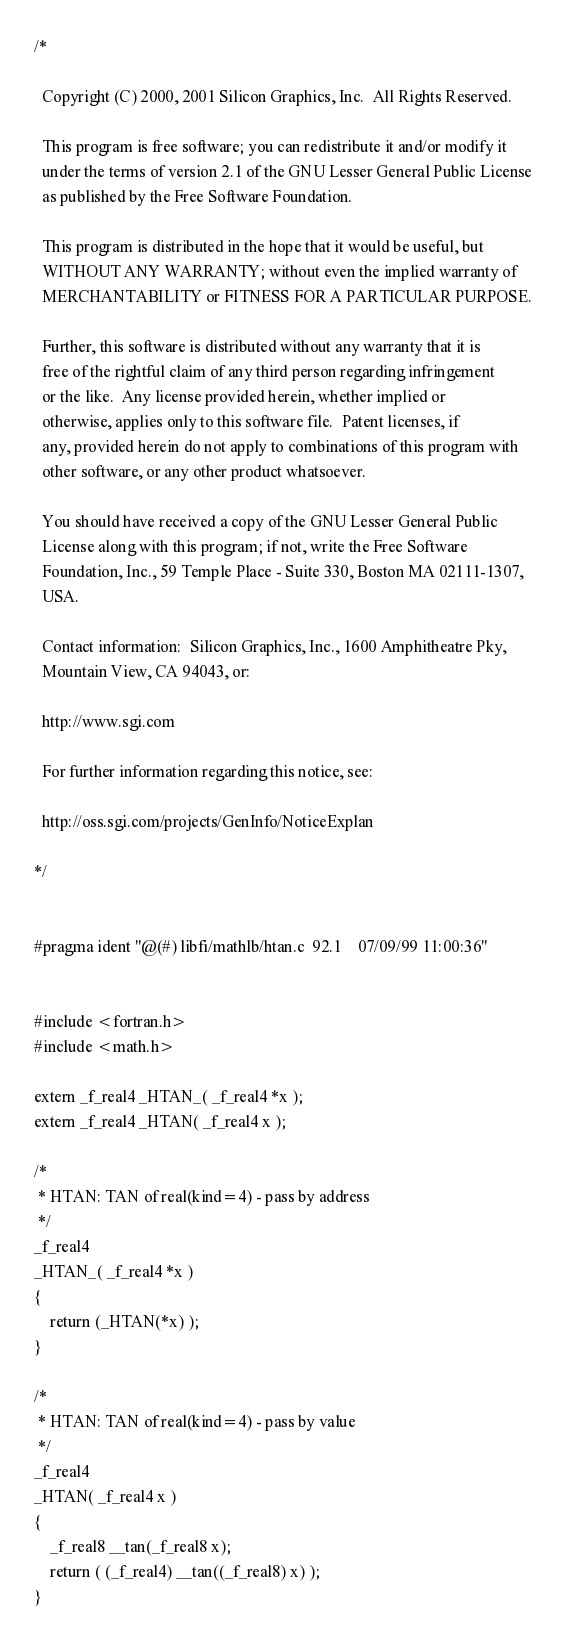Convert code to text. <code><loc_0><loc_0><loc_500><loc_500><_C_>/*

  Copyright (C) 2000, 2001 Silicon Graphics, Inc.  All Rights Reserved.

  This program is free software; you can redistribute it and/or modify it
  under the terms of version 2.1 of the GNU Lesser General Public License 
  as published by the Free Software Foundation.

  This program is distributed in the hope that it would be useful, but
  WITHOUT ANY WARRANTY; without even the implied warranty of
  MERCHANTABILITY or FITNESS FOR A PARTICULAR PURPOSE.  

  Further, this software is distributed without any warranty that it is
  free of the rightful claim of any third person regarding infringement 
  or the like.  Any license provided herein, whether implied or 
  otherwise, applies only to this software file.  Patent licenses, if
  any, provided herein do not apply to combinations of this program with 
  other software, or any other product whatsoever.  

  You should have received a copy of the GNU Lesser General Public 
  License along with this program; if not, write the Free Software 
  Foundation, Inc., 59 Temple Place - Suite 330, Boston MA 02111-1307, 
  USA.

  Contact information:  Silicon Graphics, Inc., 1600 Amphitheatre Pky,
  Mountain View, CA 94043, or:

  http://www.sgi.com

  For further information regarding this notice, see:

  http://oss.sgi.com/projects/GenInfo/NoticeExplan

*/


#pragma ident "@(#) libfi/mathlb/htan.c	92.1	07/09/99 11:00:36"


#include <fortran.h>
#include <math.h>

extern _f_real4 _HTAN_( _f_real4 *x );
extern _f_real4 _HTAN( _f_real4 x );

/*
 * HTAN: TAN of real(kind=4) - pass by address
 */
_f_real4
_HTAN_( _f_real4 *x )
{
	return (_HTAN(*x) );
}

/*
 * HTAN: TAN of real(kind=4) - pass by value
 */
_f_real4
_HTAN( _f_real4 x )
{
	_f_real8 __tan(_f_real8 x);
	return ( (_f_real4) __tan((_f_real8) x) );
}
</code> 